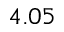Convert formula to latex. <formula><loc_0><loc_0><loc_500><loc_500>4 . 0 5</formula> 